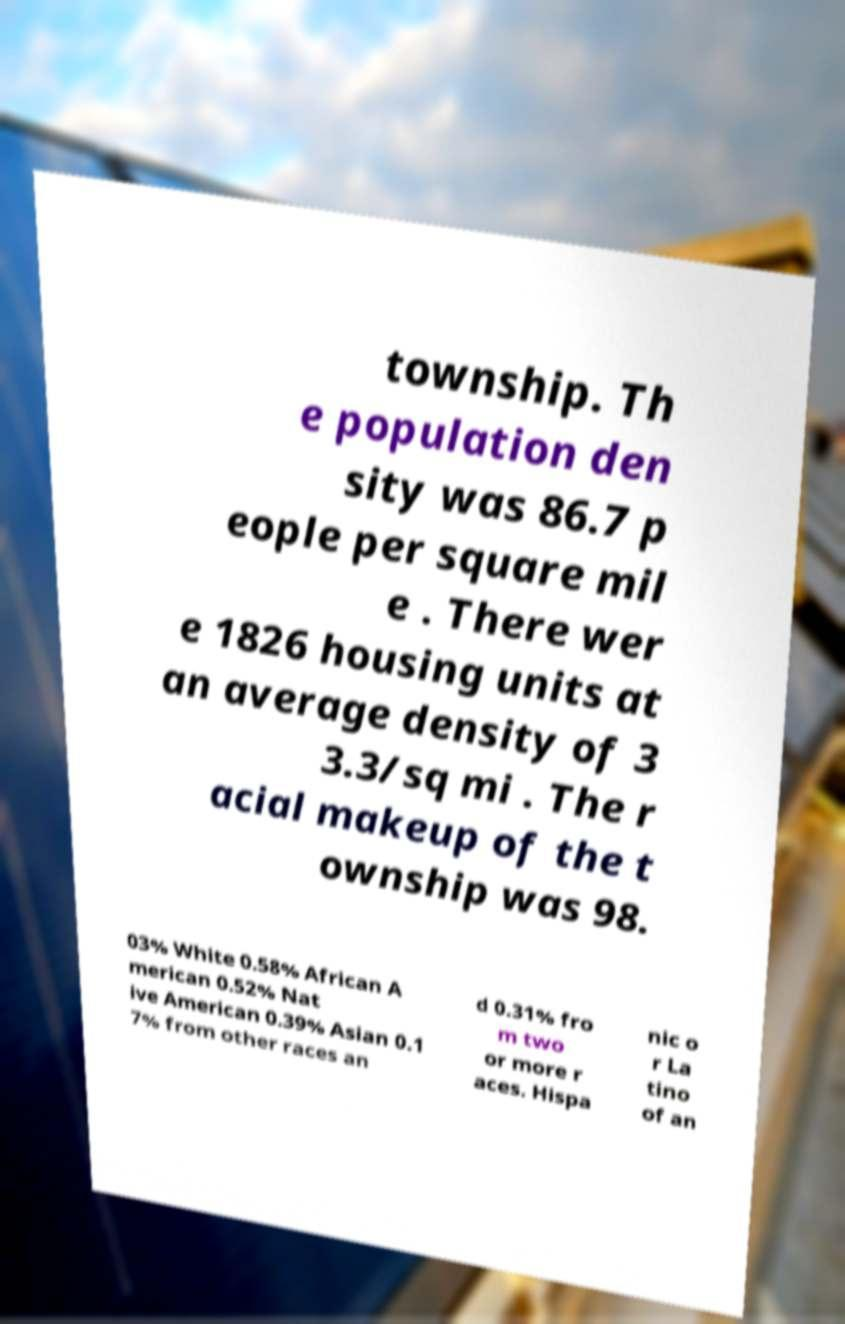Can you accurately transcribe the text from the provided image for me? township. Th e population den sity was 86.7 p eople per square mil e . There wer e 1826 housing units at an average density of 3 3.3/sq mi . The r acial makeup of the t ownship was 98. 03% White 0.58% African A merican 0.52% Nat ive American 0.39% Asian 0.1 7% from other races an d 0.31% fro m two or more r aces. Hispa nic o r La tino of an 